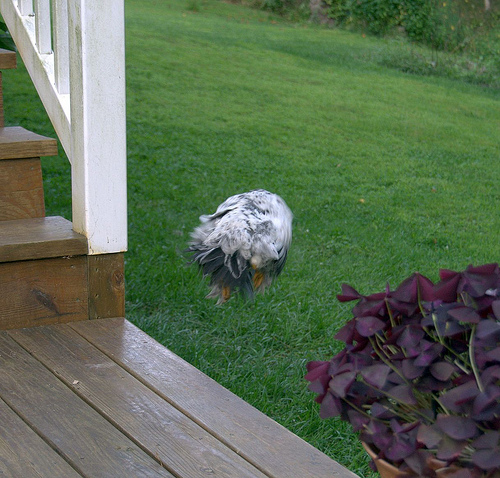<image>
Is there a bird in the flowers? No. The bird is not contained within the flowers. These objects have a different spatial relationship. Where is the plant in relation to the porch? Is it next to the porch? Yes. The plant is positioned adjacent to the porch, located nearby in the same general area. Is there a hen in front of the building? No. The hen is not in front of the building. The spatial positioning shows a different relationship between these objects. Where is the stair in relation to the grass? Is it above the grass? Yes. The stair is positioned above the grass in the vertical space, higher up in the scene. 